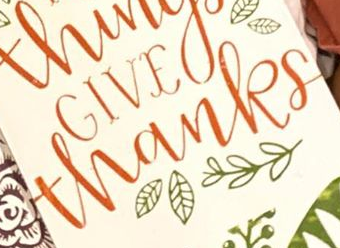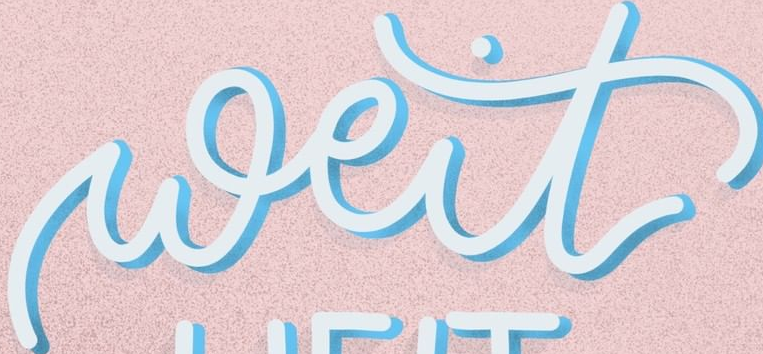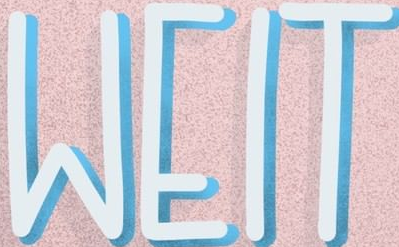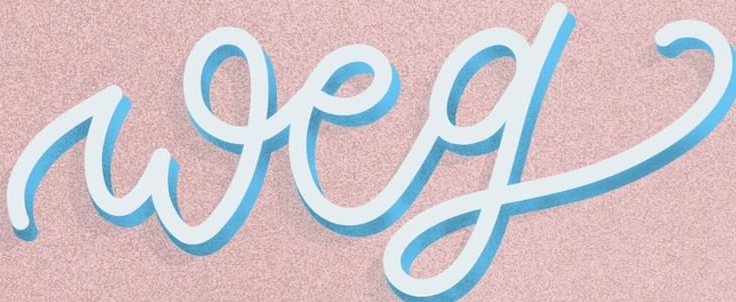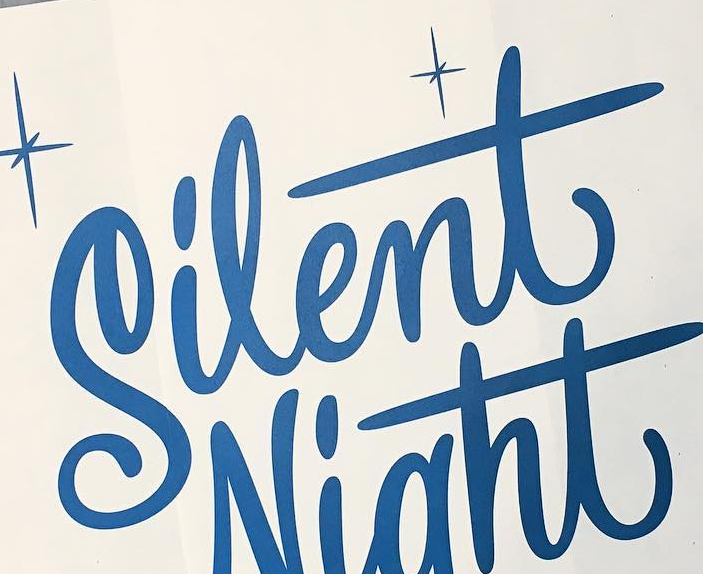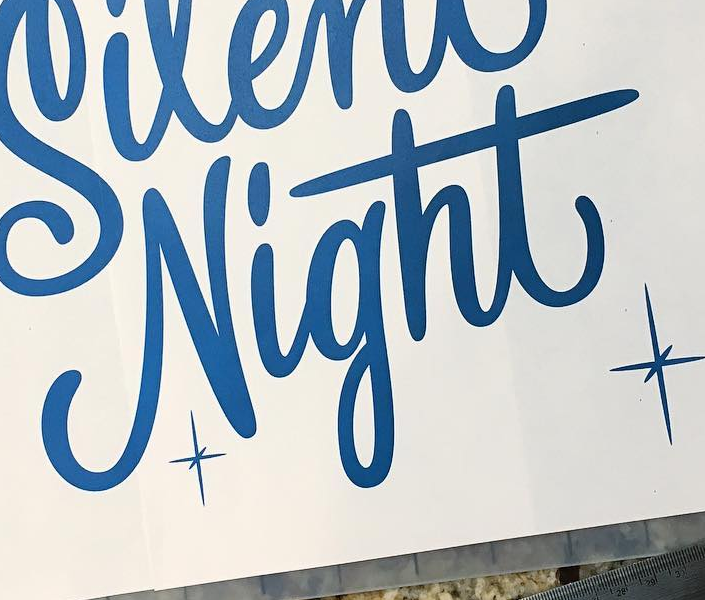What text appears in these images from left to right, separated by a semicolon? thanks; weit; WEIT; weg; Silent; Night 